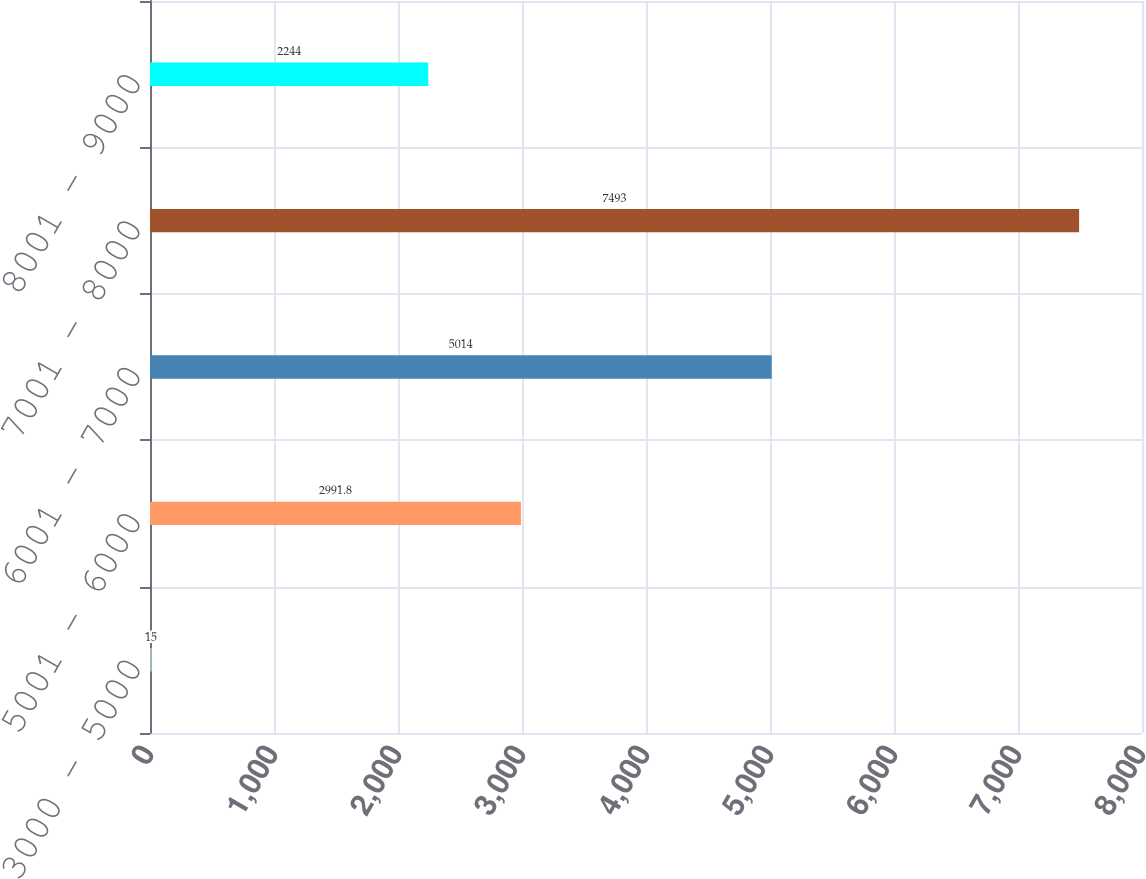<chart> <loc_0><loc_0><loc_500><loc_500><bar_chart><fcel>3000 - 5000<fcel>5001 - 6000<fcel>6001 - 7000<fcel>7001 - 8000<fcel>8001 - 9000<nl><fcel>15<fcel>2991.8<fcel>5014<fcel>7493<fcel>2244<nl></chart> 